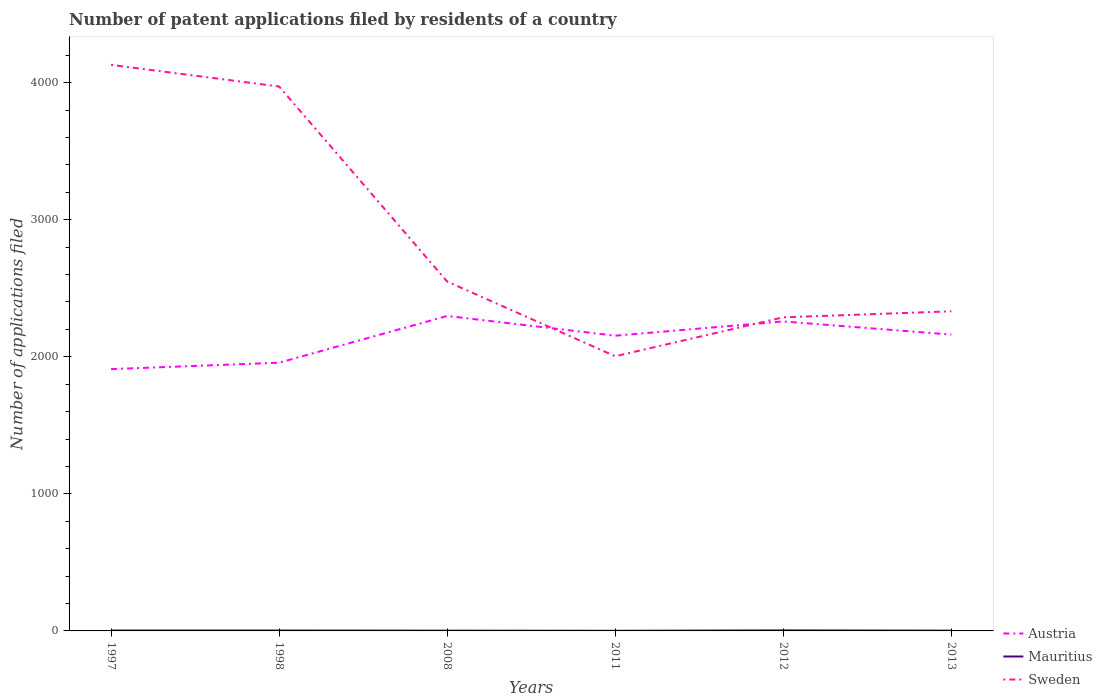How many different coloured lines are there?
Provide a short and direct response. 3. Is the number of lines equal to the number of legend labels?
Make the answer very short. Yes. Across all years, what is the maximum number of applications filed in Austria?
Your answer should be compact. 1910. What is the difference between the highest and the second highest number of applications filed in Sweden?
Give a very brief answer. 2126. How many lines are there?
Ensure brevity in your answer.  3. How many years are there in the graph?
Your answer should be compact. 6. Are the values on the major ticks of Y-axis written in scientific E-notation?
Make the answer very short. No. Does the graph contain any zero values?
Provide a short and direct response. No. How many legend labels are there?
Ensure brevity in your answer.  3. How are the legend labels stacked?
Your answer should be very brief. Vertical. What is the title of the graph?
Offer a terse response. Number of patent applications filed by residents of a country. What is the label or title of the Y-axis?
Keep it short and to the point. Number of applications filed. What is the Number of applications filed of Austria in 1997?
Provide a succinct answer. 1910. What is the Number of applications filed of Sweden in 1997?
Keep it short and to the point. 4130. What is the Number of applications filed in Austria in 1998?
Make the answer very short. 1957. What is the Number of applications filed of Sweden in 1998?
Offer a very short reply. 3972. What is the Number of applications filed in Austria in 2008?
Offer a terse response. 2298. What is the Number of applications filed in Sweden in 2008?
Ensure brevity in your answer.  2549. What is the Number of applications filed of Austria in 2011?
Provide a short and direct response. 2154. What is the Number of applications filed in Mauritius in 2011?
Offer a very short reply. 1. What is the Number of applications filed of Sweden in 2011?
Offer a terse response. 2004. What is the Number of applications filed of Austria in 2012?
Provide a short and direct response. 2258. What is the Number of applications filed of Sweden in 2012?
Your answer should be compact. 2288. What is the Number of applications filed in Austria in 2013?
Your answer should be compact. 2162. What is the Number of applications filed of Sweden in 2013?
Your response must be concise. 2332. Across all years, what is the maximum Number of applications filed in Austria?
Provide a short and direct response. 2298. Across all years, what is the maximum Number of applications filed of Mauritius?
Your response must be concise. 4. Across all years, what is the maximum Number of applications filed of Sweden?
Your answer should be compact. 4130. Across all years, what is the minimum Number of applications filed of Austria?
Keep it short and to the point. 1910. Across all years, what is the minimum Number of applications filed of Sweden?
Provide a succinct answer. 2004. What is the total Number of applications filed in Austria in the graph?
Give a very brief answer. 1.27e+04. What is the total Number of applications filed in Sweden in the graph?
Ensure brevity in your answer.  1.73e+04. What is the difference between the Number of applications filed in Austria in 1997 and that in 1998?
Offer a very short reply. -47. What is the difference between the Number of applications filed in Sweden in 1997 and that in 1998?
Offer a terse response. 158. What is the difference between the Number of applications filed in Austria in 1997 and that in 2008?
Provide a short and direct response. -388. What is the difference between the Number of applications filed of Mauritius in 1997 and that in 2008?
Make the answer very short. 1. What is the difference between the Number of applications filed of Sweden in 1997 and that in 2008?
Offer a very short reply. 1581. What is the difference between the Number of applications filed in Austria in 1997 and that in 2011?
Keep it short and to the point. -244. What is the difference between the Number of applications filed of Mauritius in 1997 and that in 2011?
Give a very brief answer. 2. What is the difference between the Number of applications filed of Sweden in 1997 and that in 2011?
Your answer should be compact. 2126. What is the difference between the Number of applications filed of Austria in 1997 and that in 2012?
Provide a succinct answer. -348. What is the difference between the Number of applications filed of Mauritius in 1997 and that in 2012?
Ensure brevity in your answer.  -1. What is the difference between the Number of applications filed in Sweden in 1997 and that in 2012?
Offer a very short reply. 1842. What is the difference between the Number of applications filed in Austria in 1997 and that in 2013?
Offer a very short reply. -252. What is the difference between the Number of applications filed of Sweden in 1997 and that in 2013?
Your answer should be compact. 1798. What is the difference between the Number of applications filed in Austria in 1998 and that in 2008?
Your answer should be compact. -341. What is the difference between the Number of applications filed of Mauritius in 1998 and that in 2008?
Offer a very short reply. 1. What is the difference between the Number of applications filed in Sweden in 1998 and that in 2008?
Provide a short and direct response. 1423. What is the difference between the Number of applications filed in Austria in 1998 and that in 2011?
Make the answer very short. -197. What is the difference between the Number of applications filed in Sweden in 1998 and that in 2011?
Keep it short and to the point. 1968. What is the difference between the Number of applications filed of Austria in 1998 and that in 2012?
Give a very brief answer. -301. What is the difference between the Number of applications filed in Mauritius in 1998 and that in 2012?
Your response must be concise. -1. What is the difference between the Number of applications filed of Sweden in 1998 and that in 2012?
Your answer should be compact. 1684. What is the difference between the Number of applications filed of Austria in 1998 and that in 2013?
Give a very brief answer. -205. What is the difference between the Number of applications filed of Sweden in 1998 and that in 2013?
Ensure brevity in your answer.  1640. What is the difference between the Number of applications filed in Austria in 2008 and that in 2011?
Give a very brief answer. 144. What is the difference between the Number of applications filed in Mauritius in 2008 and that in 2011?
Make the answer very short. 1. What is the difference between the Number of applications filed of Sweden in 2008 and that in 2011?
Provide a succinct answer. 545. What is the difference between the Number of applications filed of Mauritius in 2008 and that in 2012?
Your answer should be compact. -2. What is the difference between the Number of applications filed of Sweden in 2008 and that in 2012?
Your answer should be compact. 261. What is the difference between the Number of applications filed in Austria in 2008 and that in 2013?
Offer a very short reply. 136. What is the difference between the Number of applications filed of Sweden in 2008 and that in 2013?
Offer a terse response. 217. What is the difference between the Number of applications filed of Austria in 2011 and that in 2012?
Your response must be concise. -104. What is the difference between the Number of applications filed of Sweden in 2011 and that in 2012?
Keep it short and to the point. -284. What is the difference between the Number of applications filed of Mauritius in 2011 and that in 2013?
Give a very brief answer. -1. What is the difference between the Number of applications filed in Sweden in 2011 and that in 2013?
Offer a terse response. -328. What is the difference between the Number of applications filed of Austria in 2012 and that in 2013?
Offer a terse response. 96. What is the difference between the Number of applications filed in Mauritius in 2012 and that in 2013?
Your answer should be very brief. 2. What is the difference between the Number of applications filed in Sweden in 2012 and that in 2013?
Your answer should be very brief. -44. What is the difference between the Number of applications filed in Austria in 1997 and the Number of applications filed in Mauritius in 1998?
Offer a terse response. 1907. What is the difference between the Number of applications filed of Austria in 1997 and the Number of applications filed of Sweden in 1998?
Give a very brief answer. -2062. What is the difference between the Number of applications filed of Mauritius in 1997 and the Number of applications filed of Sweden in 1998?
Give a very brief answer. -3969. What is the difference between the Number of applications filed of Austria in 1997 and the Number of applications filed of Mauritius in 2008?
Your answer should be very brief. 1908. What is the difference between the Number of applications filed of Austria in 1997 and the Number of applications filed of Sweden in 2008?
Provide a succinct answer. -639. What is the difference between the Number of applications filed of Mauritius in 1997 and the Number of applications filed of Sweden in 2008?
Keep it short and to the point. -2546. What is the difference between the Number of applications filed in Austria in 1997 and the Number of applications filed in Mauritius in 2011?
Provide a short and direct response. 1909. What is the difference between the Number of applications filed in Austria in 1997 and the Number of applications filed in Sweden in 2011?
Give a very brief answer. -94. What is the difference between the Number of applications filed of Mauritius in 1997 and the Number of applications filed of Sweden in 2011?
Keep it short and to the point. -2001. What is the difference between the Number of applications filed in Austria in 1997 and the Number of applications filed in Mauritius in 2012?
Your response must be concise. 1906. What is the difference between the Number of applications filed in Austria in 1997 and the Number of applications filed in Sweden in 2012?
Give a very brief answer. -378. What is the difference between the Number of applications filed of Mauritius in 1997 and the Number of applications filed of Sweden in 2012?
Provide a short and direct response. -2285. What is the difference between the Number of applications filed of Austria in 1997 and the Number of applications filed of Mauritius in 2013?
Provide a succinct answer. 1908. What is the difference between the Number of applications filed in Austria in 1997 and the Number of applications filed in Sweden in 2013?
Your answer should be compact. -422. What is the difference between the Number of applications filed of Mauritius in 1997 and the Number of applications filed of Sweden in 2013?
Ensure brevity in your answer.  -2329. What is the difference between the Number of applications filed in Austria in 1998 and the Number of applications filed in Mauritius in 2008?
Provide a succinct answer. 1955. What is the difference between the Number of applications filed in Austria in 1998 and the Number of applications filed in Sweden in 2008?
Your answer should be very brief. -592. What is the difference between the Number of applications filed of Mauritius in 1998 and the Number of applications filed of Sweden in 2008?
Give a very brief answer. -2546. What is the difference between the Number of applications filed in Austria in 1998 and the Number of applications filed in Mauritius in 2011?
Your answer should be very brief. 1956. What is the difference between the Number of applications filed in Austria in 1998 and the Number of applications filed in Sweden in 2011?
Give a very brief answer. -47. What is the difference between the Number of applications filed in Mauritius in 1998 and the Number of applications filed in Sweden in 2011?
Ensure brevity in your answer.  -2001. What is the difference between the Number of applications filed in Austria in 1998 and the Number of applications filed in Mauritius in 2012?
Your answer should be very brief. 1953. What is the difference between the Number of applications filed of Austria in 1998 and the Number of applications filed of Sweden in 2012?
Offer a very short reply. -331. What is the difference between the Number of applications filed of Mauritius in 1998 and the Number of applications filed of Sweden in 2012?
Provide a succinct answer. -2285. What is the difference between the Number of applications filed in Austria in 1998 and the Number of applications filed in Mauritius in 2013?
Provide a short and direct response. 1955. What is the difference between the Number of applications filed in Austria in 1998 and the Number of applications filed in Sweden in 2013?
Keep it short and to the point. -375. What is the difference between the Number of applications filed of Mauritius in 1998 and the Number of applications filed of Sweden in 2013?
Your answer should be very brief. -2329. What is the difference between the Number of applications filed in Austria in 2008 and the Number of applications filed in Mauritius in 2011?
Keep it short and to the point. 2297. What is the difference between the Number of applications filed of Austria in 2008 and the Number of applications filed of Sweden in 2011?
Your response must be concise. 294. What is the difference between the Number of applications filed in Mauritius in 2008 and the Number of applications filed in Sweden in 2011?
Give a very brief answer. -2002. What is the difference between the Number of applications filed in Austria in 2008 and the Number of applications filed in Mauritius in 2012?
Your answer should be compact. 2294. What is the difference between the Number of applications filed in Mauritius in 2008 and the Number of applications filed in Sweden in 2012?
Keep it short and to the point. -2286. What is the difference between the Number of applications filed of Austria in 2008 and the Number of applications filed of Mauritius in 2013?
Your answer should be very brief. 2296. What is the difference between the Number of applications filed in Austria in 2008 and the Number of applications filed in Sweden in 2013?
Your response must be concise. -34. What is the difference between the Number of applications filed of Mauritius in 2008 and the Number of applications filed of Sweden in 2013?
Keep it short and to the point. -2330. What is the difference between the Number of applications filed of Austria in 2011 and the Number of applications filed of Mauritius in 2012?
Give a very brief answer. 2150. What is the difference between the Number of applications filed in Austria in 2011 and the Number of applications filed in Sweden in 2012?
Make the answer very short. -134. What is the difference between the Number of applications filed of Mauritius in 2011 and the Number of applications filed of Sweden in 2012?
Your answer should be very brief. -2287. What is the difference between the Number of applications filed in Austria in 2011 and the Number of applications filed in Mauritius in 2013?
Provide a succinct answer. 2152. What is the difference between the Number of applications filed in Austria in 2011 and the Number of applications filed in Sweden in 2013?
Keep it short and to the point. -178. What is the difference between the Number of applications filed of Mauritius in 2011 and the Number of applications filed of Sweden in 2013?
Your response must be concise. -2331. What is the difference between the Number of applications filed in Austria in 2012 and the Number of applications filed in Mauritius in 2013?
Give a very brief answer. 2256. What is the difference between the Number of applications filed of Austria in 2012 and the Number of applications filed of Sweden in 2013?
Offer a very short reply. -74. What is the difference between the Number of applications filed in Mauritius in 2012 and the Number of applications filed in Sweden in 2013?
Your response must be concise. -2328. What is the average Number of applications filed in Austria per year?
Your response must be concise. 2123.17. What is the average Number of applications filed in Sweden per year?
Keep it short and to the point. 2879.17. In the year 1997, what is the difference between the Number of applications filed in Austria and Number of applications filed in Mauritius?
Provide a succinct answer. 1907. In the year 1997, what is the difference between the Number of applications filed of Austria and Number of applications filed of Sweden?
Your answer should be compact. -2220. In the year 1997, what is the difference between the Number of applications filed of Mauritius and Number of applications filed of Sweden?
Your answer should be very brief. -4127. In the year 1998, what is the difference between the Number of applications filed of Austria and Number of applications filed of Mauritius?
Your response must be concise. 1954. In the year 1998, what is the difference between the Number of applications filed of Austria and Number of applications filed of Sweden?
Offer a very short reply. -2015. In the year 1998, what is the difference between the Number of applications filed of Mauritius and Number of applications filed of Sweden?
Your response must be concise. -3969. In the year 2008, what is the difference between the Number of applications filed in Austria and Number of applications filed in Mauritius?
Offer a terse response. 2296. In the year 2008, what is the difference between the Number of applications filed in Austria and Number of applications filed in Sweden?
Provide a short and direct response. -251. In the year 2008, what is the difference between the Number of applications filed in Mauritius and Number of applications filed in Sweden?
Give a very brief answer. -2547. In the year 2011, what is the difference between the Number of applications filed of Austria and Number of applications filed of Mauritius?
Provide a short and direct response. 2153. In the year 2011, what is the difference between the Number of applications filed of Austria and Number of applications filed of Sweden?
Ensure brevity in your answer.  150. In the year 2011, what is the difference between the Number of applications filed in Mauritius and Number of applications filed in Sweden?
Your response must be concise. -2003. In the year 2012, what is the difference between the Number of applications filed of Austria and Number of applications filed of Mauritius?
Your answer should be compact. 2254. In the year 2012, what is the difference between the Number of applications filed in Mauritius and Number of applications filed in Sweden?
Provide a short and direct response. -2284. In the year 2013, what is the difference between the Number of applications filed of Austria and Number of applications filed of Mauritius?
Offer a very short reply. 2160. In the year 2013, what is the difference between the Number of applications filed in Austria and Number of applications filed in Sweden?
Your answer should be compact. -170. In the year 2013, what is the difference between the Number of applications filed of Mauritius and Number of applications filed of Sweden?
Provide a succinct answer. -2330. What is the ratio of the Number of applications filed in Austria in 1997 to that in 1998?
Your answer should be compact. 0.98. What is the ratio of the Number of applications filed in Mauritius in 1997 to that in 1998?
Keep it short and to the point. 1. What is the ratio of the Number of applications filed of Sweden in 1997 to that in 1998?
Your answer should be compact. 1.04. What is the ratio of the Number of applications filed of Austria in 1997 to that in 2008?
Make the answer very short. 0.83. What is the ratio of the Number of applications filed of Mauritius in 1997 to that in 2008?
Offer a very short reply. 1.5. What is the ratio of the Number of applications filed in Sweden in 1997 to that in 2008?
Offer a very short reply. 1.62. What is the ratio of the Number of applications filed of Austria in 1997 to that in 2011?
Offer a terse response. 0.89. What is the ratio of the Number of applications filed in Mauritius in 1997 to that in 2011?
Ensure brevity in your answer.  3. What is the ratio of the Number of applications filed of Sweden in 1997 to that in 2011?
Your answer should be very brief. 2.06. What is the ratio of the Number of applications filed of Austria in 1997 to that in 2012?
Offer a terse response. 0.85. What is the ratio of the Number of applications filed in Sweden in 1997 to that in 2012?
Give a very brief answer. 1.81. What is the ratio of the Number of applications filed in Austria in 1997 to that in 2013?
Make the answer very short. 0.88. What is the ratio of the Number of applications filed in Mauritius in 1997 to that in 2013?
Offer a terse response. 1.5. What is the ratio of the Number of applications filed of Sweden in 1997 to that in 2013?
Ensure brevity in your answer.  1.77. What is the ratio of the Number of applications filed of Austria in 1998 to that in 2008?
Keep it short and to the point. 0.85. What is the ratio of the Number of applications filed of Mauritius in 1998 to that in 2008?
Provide a short and direct response. 1.5. What is the ratio of the Number of applications filed in Sweden in 1998 to that in 2008?
Provide a short and direct response. 1.56. What is the ratio of the Number of applications filed in Austria in 1998 to that in 2011?
Your response must be concise. 0.91. What is the ratio of the Number of applications filed in Mauritius in 1998 to that in 2011?
Your answer should be very brief. 3. What is the ratio of the Number of applications filed in Sweden in 1998 to that in 2011?
Give a very brief answer. 1.98. What is the ratio of the Number of applications filed of Austria in 1998 to that in 2012?
Offer a very short reply. 0.87. What is the ratio of the Number of applications filed in Sweden in 1998 to that in 2012?
Ensure brevity in your answer.  1.74. What is the ratio of the Number of applications filed of Austria in 1998 to that in 2013?
Offer a very short reply. 0.91. What is the ratio of the Number of applications filed in Mauritius in 1998 to that in 2013?
Make the answer very short. 1.5. What is the ratio of the Number of applications filed in Sweden in 1998 to that in 2013?
Provide a succinct answer. 1.7. What is the ratio of the Number of applications filed in Austria in 2008 to that in 2011?
Offer a very short reply. 1.07. What is the ratio of the Number of applications filed in Mauritius in 2008 to that in 2011?
Your answer should be very brief. 2. What is the ratio of the Number of applications filed in Sweden in 2008 to that in 2011?
Give a very brief answer. 1.27. What is the ratio of the Number of applications filed of Austria in 2008 to that in 2012?
Offer a very short reply. 1.02. What is the ratio of the Number of applications filed of Mauritius in 2008 to that in 2012?
Ensure brevity in your answer.  0.5. What is the ratio of the Number of applications filed in Sweden in 2008 to that in 2012?
Keep it short and to the point. 1.11. What is the ratio of the Number of applications filed in Austria in 2008 to that in 2013?
Ensure brevity in your answer.  1.06. What is the ratio of the Number of applications filed of Mauritius in 2008 to that in 2013?
Make the answer very short. 1. What is the ratio of the Number of applications filed of Sweden in 2008 to that in 2013?
Offer a terse response. 1.09. What is the ratio of the Number of applications filed in Austria in 2011 to that in 2012?
Your response must be concise. 0.95. What is the ratio of the Number of applications filed in Mauritius in 2011 to that in 2012?
Keep it short and to the point. 0.25. What is the ratio of the Number of applications filed of Sweden in 2011 to that in 2012?
Your answer should be compact. 0.88. What is the ratio of the Number of applications filed of Mauritius in 2011 to that in 2013?
Provide a short and direct response. 0.5. What is the ratio of the Number of applications filed in Sweden in 2011 to that in 2013?
Give a very brief answer. 0.86. What is the ratio of the Number of applications filed of Austria in 2012 to that in 2013?
Keep it short and to the point. 1.04. What is the ratio of the Number of applications filed in Mauritius in 2012 to that in 2013?
Offer a very short reply. 2. What is the ratio of the Number of applications filed in Sweden in 2012 to that in 2013?
Your response must be concise. 0.98. What is the difference between the highest and the second highest Number of applications filed in Sweden?
Your answer should be compact. 158. What is the difference between the highest and the lowest Number of applications filed in Austria?
Your answer should be very brief. 388. What is the difference between the highest and the lowest Number of applications filed in Mauritius?
Your answer should be very brief. 3. What is the difference between the highest and the lowest Number of applications filed in Sweden?
Make the answer very short. 2126. 